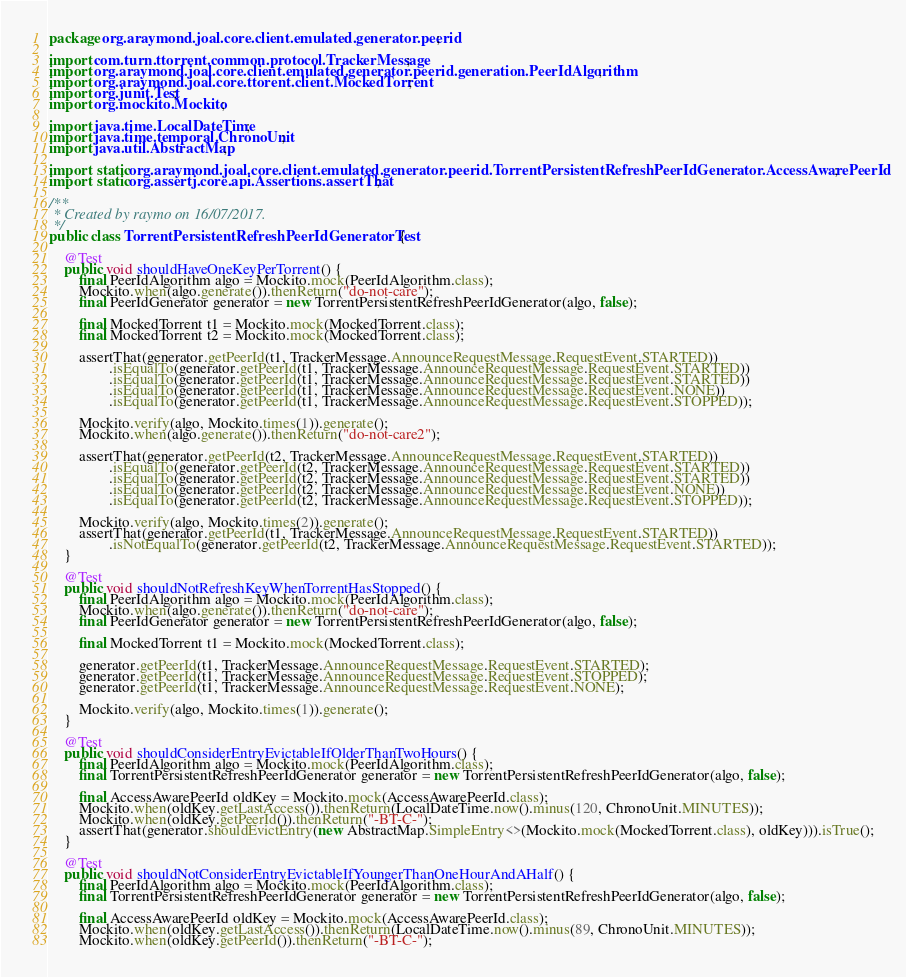Convert code to text. <code><loc_0><loc_0><loc_500><loc_500><_Java_>package org.araymond.joal.core.client.emulated.generator.peerid;

import com.turn.ttorrent.common.protocol.TrackerMessage;
import org.araymond.joal.core.client.emulated.generator.peerid.generation.PeerIdAlgorithm;
import org.araymond.joal.core.ttorent.client.MockedTorrent;
import org.junit.Test;
import org.mockito.Mockito;

import java.time.LocalDateTime;
import java.time.temporal.ChronoUnit;
import java.util.AbstractMap;

import static org.araymond.joal.core.client.emulated.generator.peerid.TorrentPersistentRefreshPeerIdGenerator.AccessAwarePeerId;
import static org.assertj.core.api.Assertions.assertThat;

/**
 * Created by raymo on 16/07/2017.
 */
public class TorrentPersistentRefreshPeerIdGeneratorTest {

    @Test
    public void shouldHaveOneKeyPerTorrent() {
        final PeerIdAlgorithm algo = Mockito.mock(PeerIdAlgorithm.class);
        Mockito.when(algo.generate()).thenReturn("do-not-care");
        final PeerIdGenerator generator = new TorrentPersistentRefreshPeerIdGenerator(algo, false);

        final MockedTorrent t1 = Mockito.mock(MockedTorrent.class);
        final MockedTorrent t2 = Mockito.mock(MockedTorrent.class);

        assertThat(generator.getPeerId(t1, TrackerMessage.AnnounceRequestMessage.RequestEvent.STARTED))
                .isEqualTo(generator.getPeerId(t1, TrackerMessage.AnnounceRequestMessage.RequestEvent.STARTED))
                .isEqualTo(generator.getPeerId(t1, TrackerMessage.AnnounceRequestMessage.RequestEvent.STARTED))
                .isEqualTo(generator.getPeerId(t1, TrackerMessage.AnnounceRequestMessage.RequestEvent.NONE))
                .isEqualTo(generator.getPeerId(t1, TrackerMessage.AnnounceRequestMessage.RequestEvent.STOPPED));

        Mockito.verify(algo, Mockito.times(1)).generate();
        Mockito.when(algo.generate()).thenReturn("do-not-care2");

        assertThat(generator.getPeerId(t2, TrackerMessage.AnnounceRequestMessage.RequestEvent.STARTED))
                .isEqualTo(generator.getPeerId(t2, TrackerMessage.AnnounceRequestMessage.RequestEvent.STARTED))
                .isEqualTo(generator.getPeerId(t2, TrackerMessage.AnnounceRequestMessage.RequestEvent.STARTED))
                .isEqualTo(generator.getPeerId(t2, TrackerMessage.AnnounceRequestMessage.RequestEvent.NONE))
                .isEqualTo(generator.getPeerId(t2, TrackerMessage.AnnounceRequestMessage.RequestEvent.STOPPED));

        Mockito.verify(algo, Mockito.times(2)).generate();
        assertThat(generator.getPeerId(t1, TrackerMessage.AnnounceRequestMessage.RequestEvent.STARTED))
                .isNotEqualTo(generator.getPeerId(t2, TrackerMessage.AnnounceRequestMessage.RequestEvent.STARTED));
    }

    @Test
    public void shouldNotRefreshKeyWhenTorrentHasStopped() {
        final PeerIdAlgorithm algo = Mockito.mock(PeerIdAlgorithm.class);
        Mockito.when(algo.generate()).thenReturn("do-not-care");
        final PeerIdGenerator generator = new TorrentPersistentRefreshPeerIdGenerator(algo, false);

        final MockedTorrent t1 = Mockito.mock(MockedTorrent.class);

        generator.getPeerId(t1, TrackerMessage.AnnounceRequestMessage.RequestEvent.STARTED);
        generator.getPeerId(t1, TrackerMessage.AnnounceRequestMessage.RequestEvent.STOPPED);
        generator.getPeerId(t1, TrackerMessage.AnnounceRequestMessage.RequestEvent.NONE);

        Mockito.verify(algo, Mockito.times(1)).generate();
    }

    @Test
    public void shouldConsiderEntryEvictableIfOlderThanTwoHours() {
        final PeerIdAlgorithm algo = Mockito.mock(PeerIdAlgorithm.class);
        final TorrentPersistentRefreshPeerIdGenerator generator = new TorrentPersistentRefreshPeerIdGenerator(algo, false);

        final AccessAwarePeerId oldKey = Mockito.mock(AccessAwarePeerId.class);
        Mockito.when(oldKey.getLastAccess()).thenReturn(LocalDateTime.now().minus(120, ChronoUnit.MINUTES));
        Mockito.when(oldKey.getPeerId()).thenReturn("-BT-C-");
        assertThat(generator.shouldEvictEntry(new AbstractMap.SimpleEntry<>(Mockito.mock(MockedTorrent.class), oldKey))).isTrue();
    }

    @Test
    public void shouldNotConsiderEntryEvictableIfYoungerThanOneHourAndAHalf() {
        final PeerIdAlgorithm algo = Mockito.mock(PeerIdAlgorithm.class);
        final TorrentPersistentRefreshPeerIdGenerator generator = new TorrentPersistentRefreshPeerIdGenerator(algo, false);

        final AccessAwarePeerId oldKey = Mockito.mock(AccessAwarePeerId.class);
        Mockito.when(oldKey.getLastAccess()).thenReturn(LocalDateTime.now().minus(89, ChronoUnit.MINUTES));
        Mockito.when(oldKey.getPeerId()).thenReturn("-BT-C-");</code> 